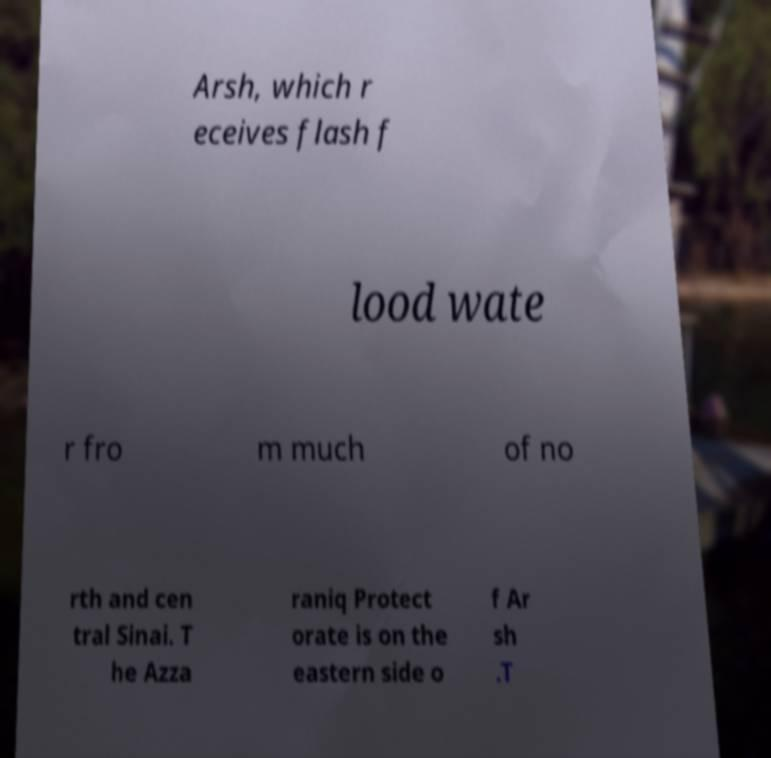Please identify and transcribe the text found in this image. Arsh, which r eceives flash f lood wate r fro m much of no rth and cen tral Sinai. T he Azza raniq Protect orate is on the eastern side o f Ar sh .T 